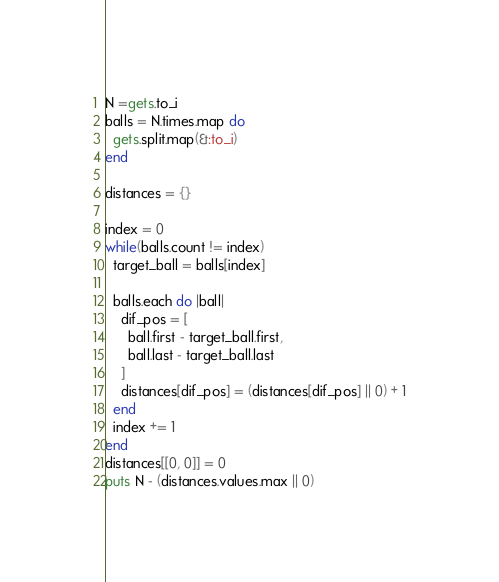Convert code to text. <code><loc_0><loc_0><loc_500><loc_500><_Ruby_>N =gets.to_i
balls = N.times.map do
  gets.split.map(&:to_i)
end

distances = {}

index = 0
while(balls.count != index)
  target_ball = balls[index]

  balls.each do |ball|
    dif_pos = [
      ball.first - target_ball.first,
      ball.last - target_ball.last
    ]
    distances[dif_pos] = (distances[dif_pos] || 0) + 1
  end
  index += 1
end
distances[[0, 0]] = 0
puts N - (distances.values.max || 0)</code> 